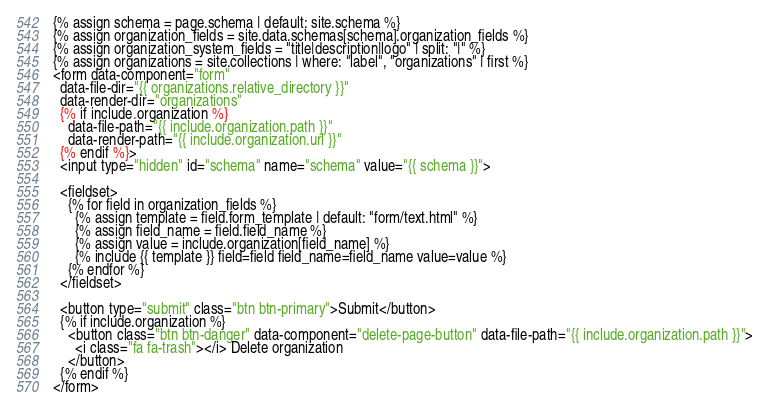Convert code to text. <code><loc_0><loc_0><loc_500><loc_500><_HTML_>{% assign schema = page.schema | default: site.schema %}
{% assign organization_fields = site.data.schemas[schema].organization_fields %}
{% assign organization_system_fields = "title|description|logo" | split: "|" %}
{% assign organizations = site.collections | where: "label", "organizations" | first %}
<form data-component="form"
  data-file-dir="{{ organizations.relative_directory }}"
  data-render-dir="organizations"
  {% if include.organization %}
    data-file-path="{{ include.organization.path }}"
    data-render-path="{{ include.organization.url }}"
  {% endif %}>
  <input type="hidden" id="schema" name="schema" value="{{ schema }}">

  <fieldset>
    {% for field in organization_fields %}
      {% assign template = field.form_template | default: "form/text.html" %}
      {% assign field_name = field.field_name %}
      {% assign value = include.organization[field_name] %}
      {% include {{ template }} field=field field_name=field_name value=value %}
    {% endfor %}
  </fieldset>

  <button type="submit" class="btn btn-primary">Submit</button>
  {% if include.organization %}
    <button class="btn btn-danger" data-component="delete-page-button" data-file-path="{{ include.organization.path }}">
      <i class="fa fa-trash"></i> Delete organization
    </button>
  {% endif %}
</form></code> 